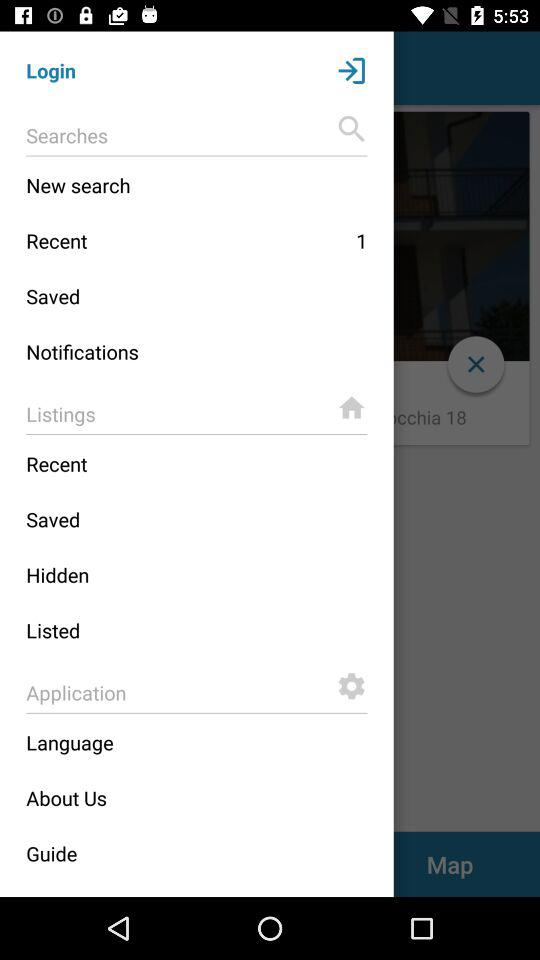How many recent items?
Answer the question using a single word or phrase. There are 1 recent items 